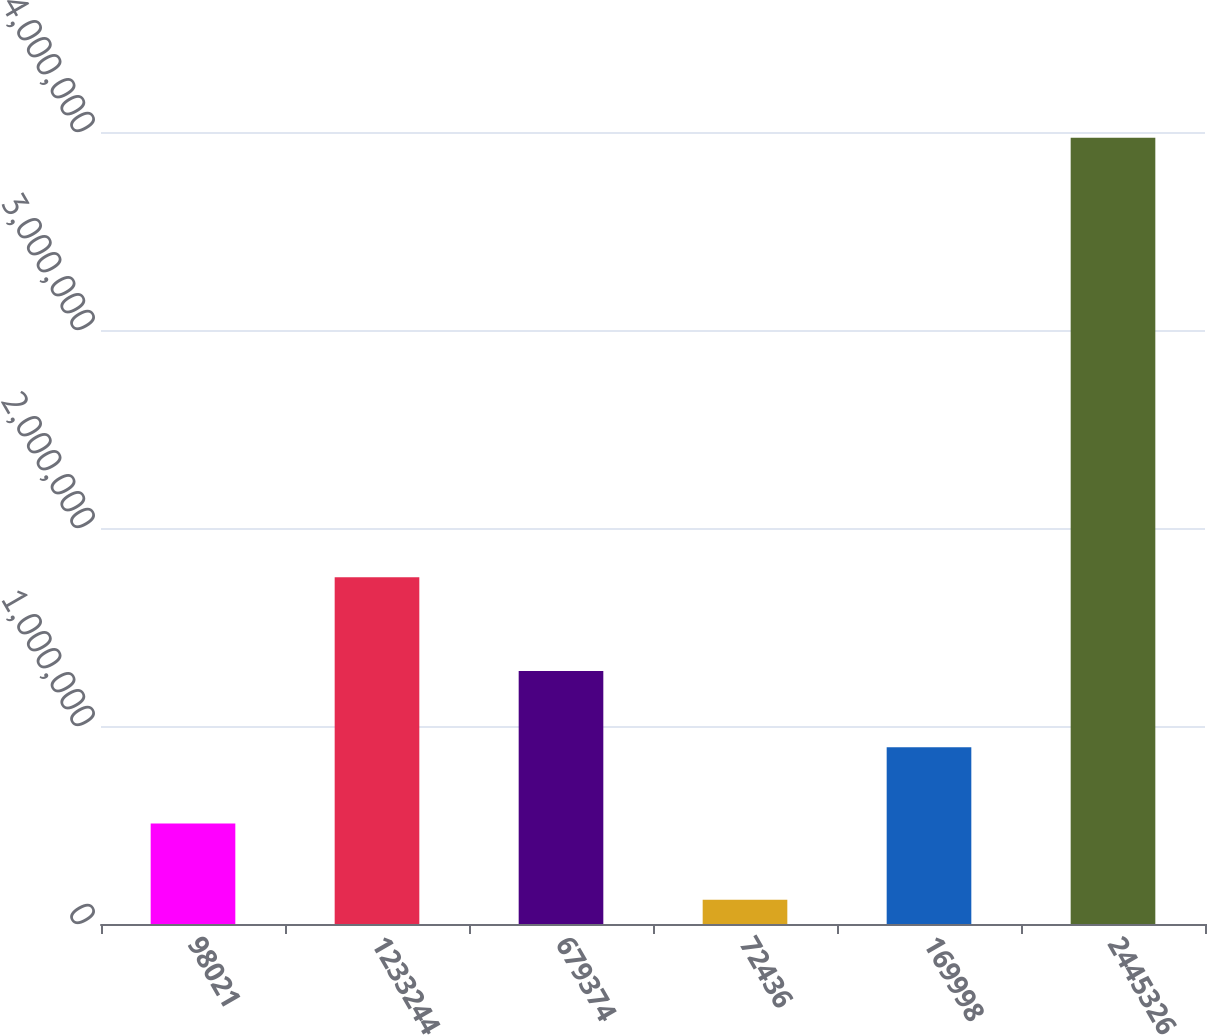Convert chart. <chart><loc_0><loc_0><loc_500><loc_500><bar_chart><fcel>98021<fcel>1233244<fcel>679374<fcel>72436<fcel>169998<fcel>2445326<nl><fcel>507778<fcel>1.75186e+06<fcel>1.27743e+06<fcel>122954<fcel>892601<fcel>3.97119e+06<nl></chart> 